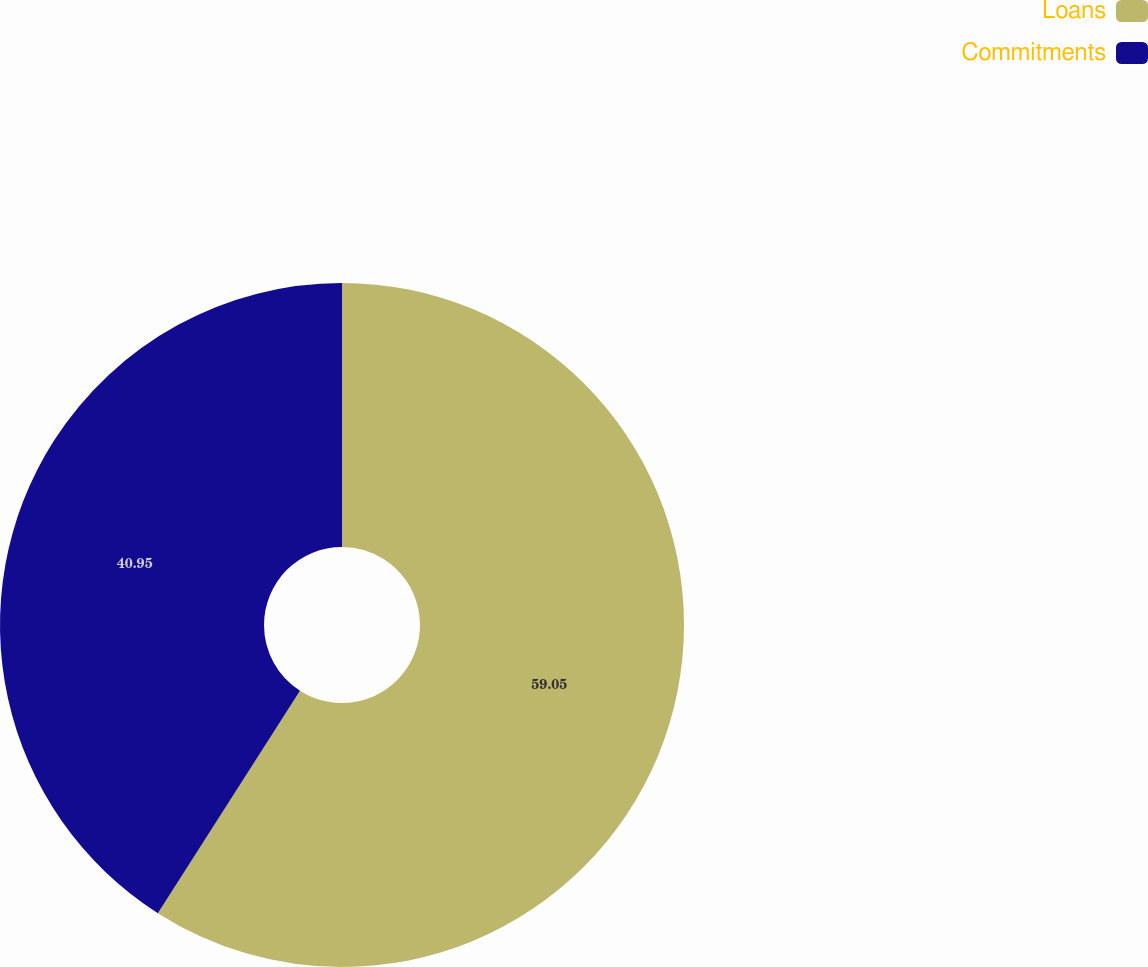Convert chart. <chart><loc_0><loc_0><loc_500><loc_500><pie_chart><fcel>Loans<fcel>Commitments<nl><fcel>59.05%<fcel>40.95%<nl></chart> 